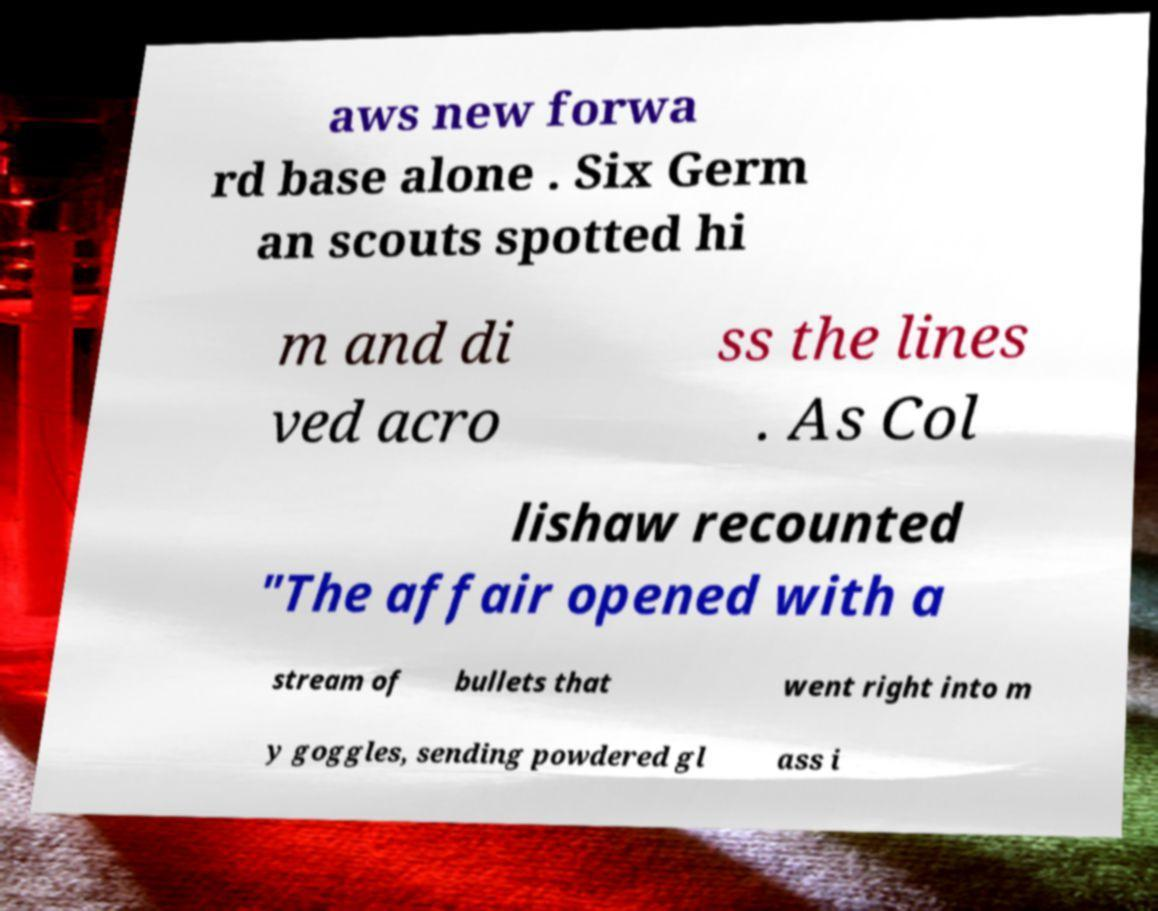Please read and relay the text visible in this image. What does it say? aws new forwa rd base alone . Six Germ an scouts spotted hi m and di ved acro ss the lines . As Col lishaw recounted "The affair opened with a stream of bullets that went right into m y goggles, sending powdered gl ass i 